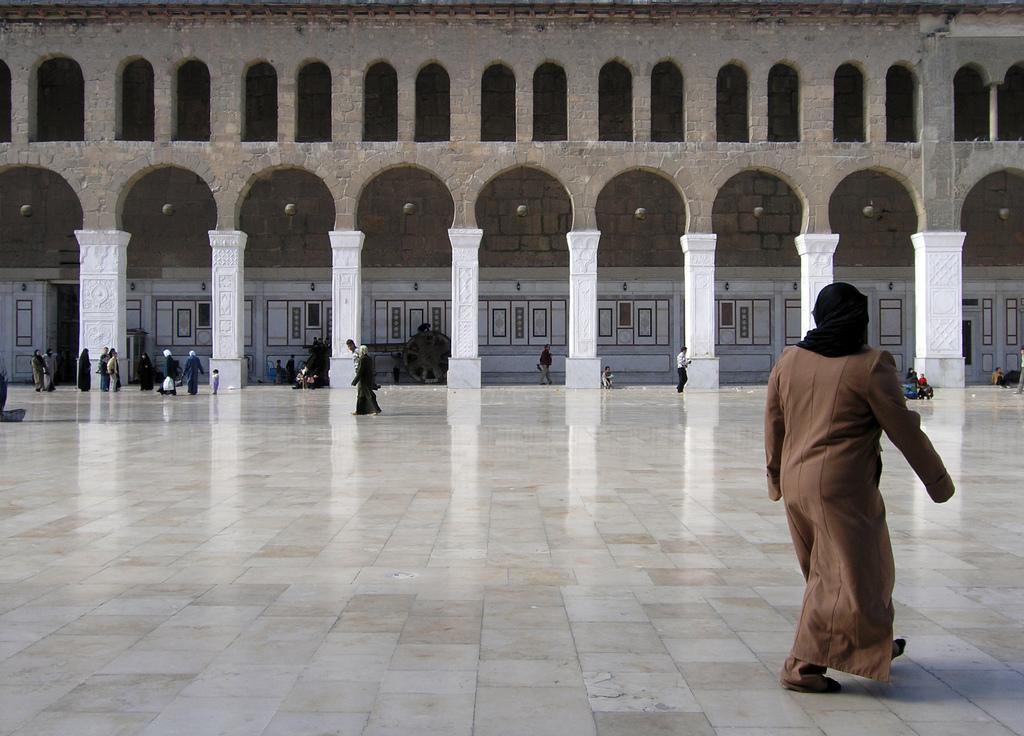Can you describe this image briefly? In this picture, there is an architecture build with bricks and pillars. Behind the pillars, there is a wall with frames. Before the pillars, there are people moving around. Towards the right, there is a woman wearing brown dress. At the bottom, there are tiles. 